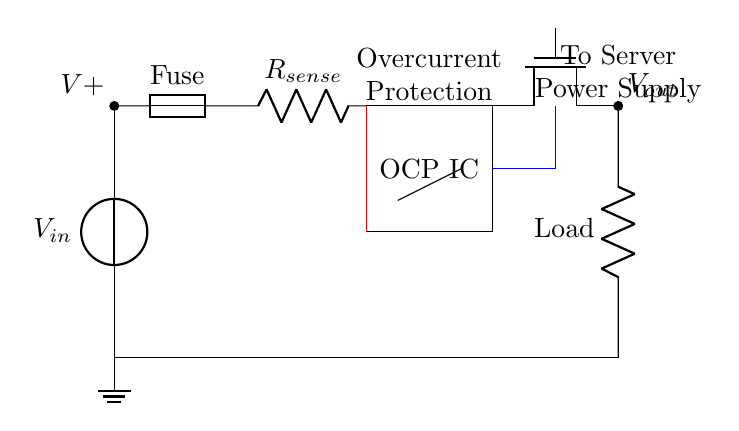What component is used for overcurrent protection? The component used for overcurrent protection in this circuit is the fuse. It is designed to break the circuit when the current exceeds a certain threshold.
Answer: Fuse What is the role of the current sense resistor? The current sense resistor measures the current flowing through the circuit. Its resistance value is selected to produce a measurable voltage drop proportional to the current, which is monitored by the OCP IC.
Answer: Current measurement What type of transistor is used to control the load? The type of transistor used to control the load in this circuit is a N-channel MOSFET, as indicated by the symbol labeled 'Tnmos'.
Answer: N-channel MOSFET How is the control signal connected to the MOSFET? The control signal is connected to the gate of the MOSFET, which is managed by the Overcurrent Protection IC. When an overcurrent is detected, the MOSFET will turn off, stopping the flow of current to the load.
Answer: Through a control line What happens to the circuit if overcurrent is detected? If overcurrent is detected, the OCP IC sends a signal to the gate of the MOSFET, turning it off and disconnecting the load from the power supply, thus protecting the system from damage.
Answer: MOSFET turns off What is the purpose of the feedback path to the OCP IC? The feedback path to the OCP IC is used to provide information about the voltage across the current sense resistor, allowing the IC to compare it against a reference value to detect overcurrent conditions.
Answer: Current comparison 